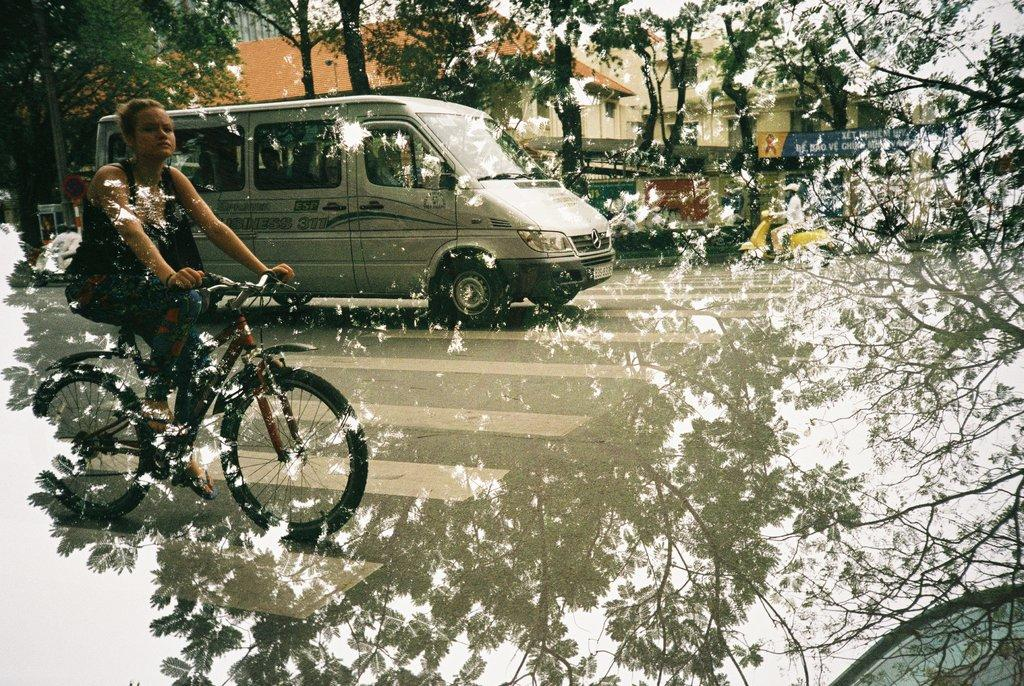Who is the main subject in the image? There is a woman in the image. What is the woman doing in the image? The woman is riding a bicycle. What else can be seen on the road in the image? There is a van on the road in the image. What type of natural and man-made structures are visible in the background? There are trees and a building visible at the back side of the image. Where is the baseball game being played in the image? There is no baseball game present in the image. What type of mask is the woman wearing in the image? The woman is not wearing a mask in the image. 